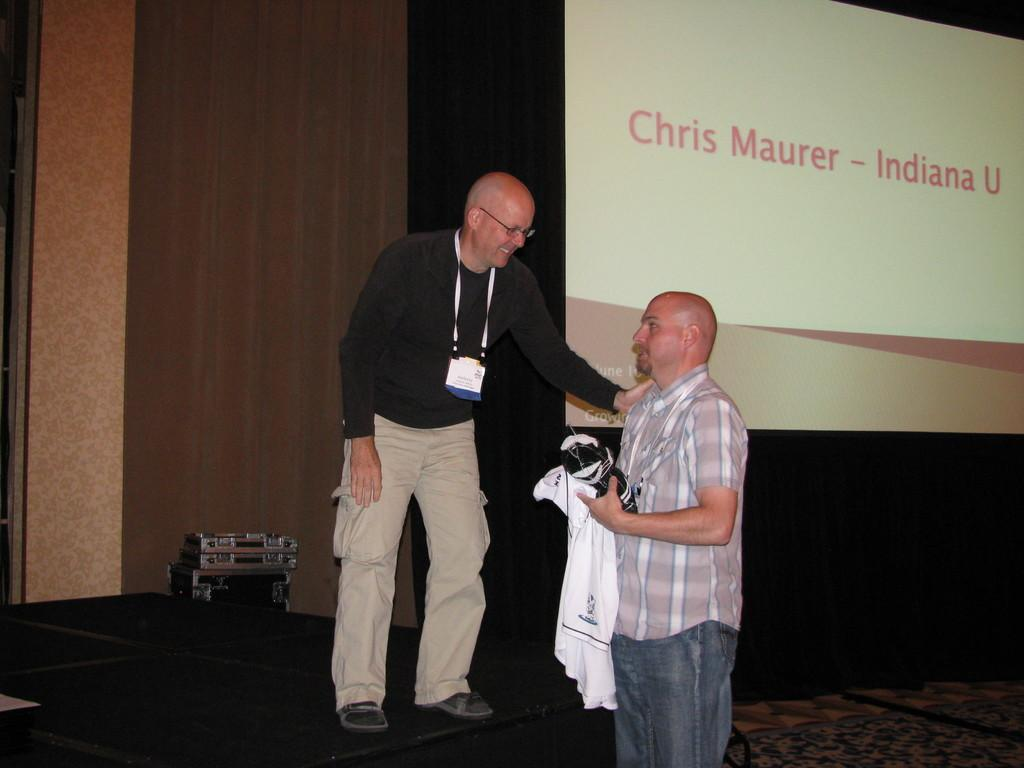What is happening on the stage in the image? There is a man standing on the stage, and another man is standing beside him. What is the second man holding in his hand? The second man is holding a cloth in his hand. What is located on the top of the stage? There is a screen on the top of the stage. What type of engine can be seen in the background of the image? There is no engine visible in the image; it features two men standing on a stage with a screen on top. 